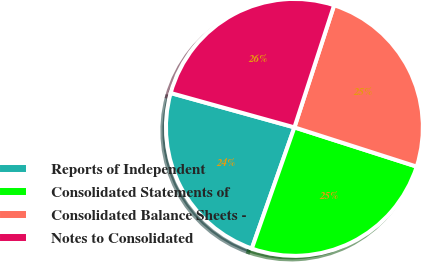Convert chart to OTSL. <chart><loc_0><loc_0><loc_500><loc_500><pie_chart><fcel>Reports of Independent<fcel>Consolidated Statements of<fcel>Consolidated Balance Sheets -<fcel>Notes to Consolidated<nl><fcel>23.93%<fcel>25.44%<fcel>24.94%<fcel>25.69%<nl></chart> 